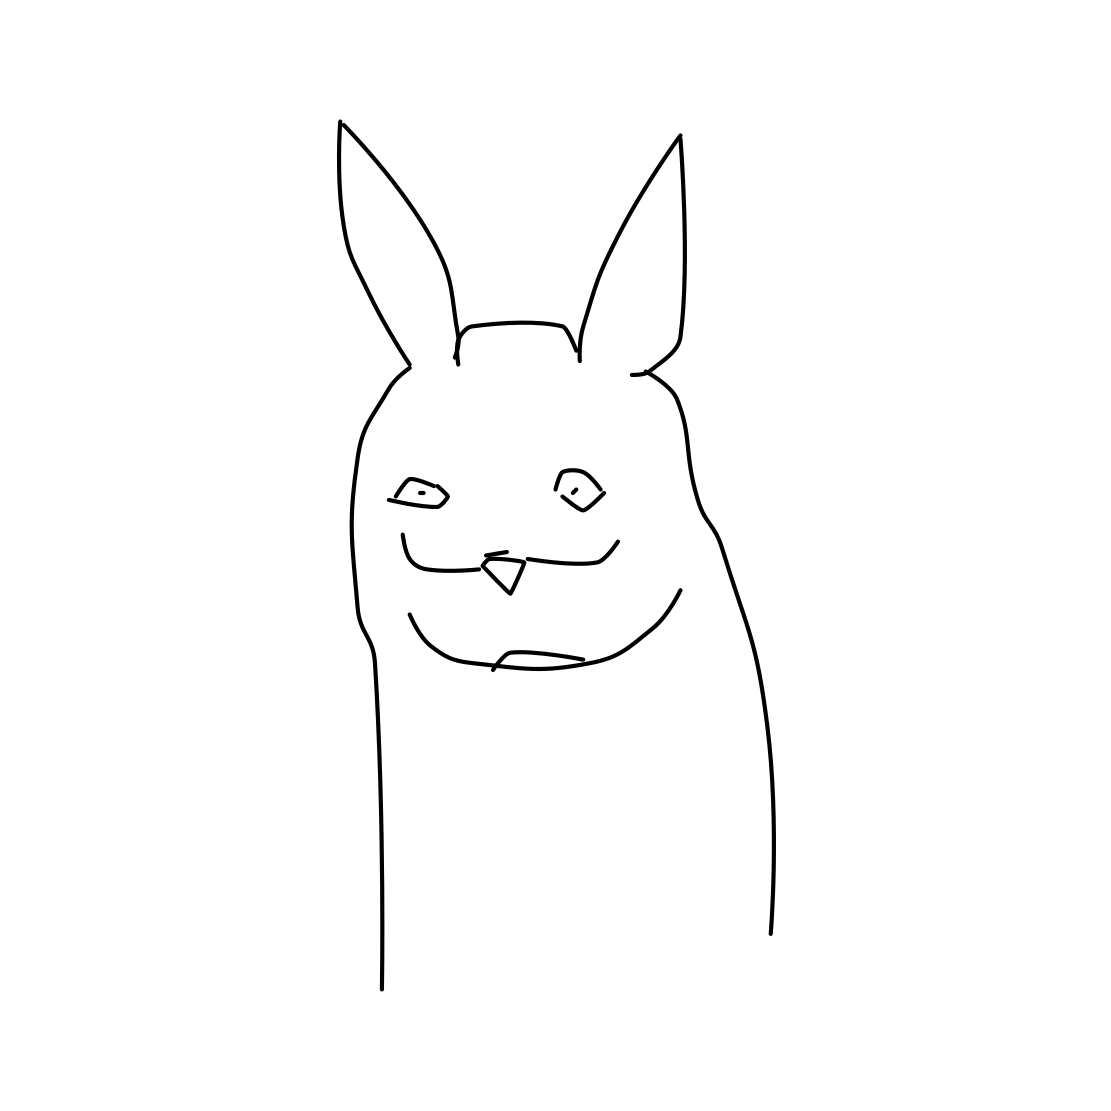Could this character be part of a larger story or narrative? Absolutely, the character's unique design and intriguing expression could make it a fascinating protagonist or a quirky side character in a whimsical tale or comic series. 